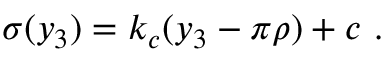<formula> <loc_0><loc_0><loc_500><loc_500>\sigma ( y _ { 3 } ) = k _ { c } ( y _ { 3 } - \pi \rho ) + c . \,</formula> 